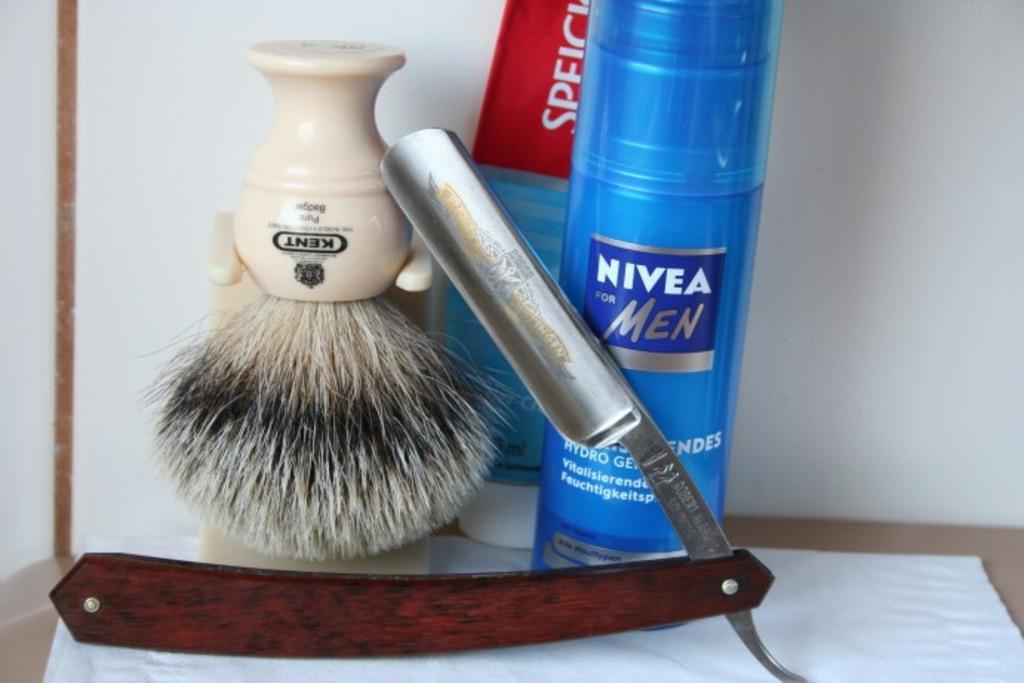What brand is the shaving brush?
Offer a terse response. Kent. What is the brand name of the shaving cream?
Keep it short and to the point. Nivea. 